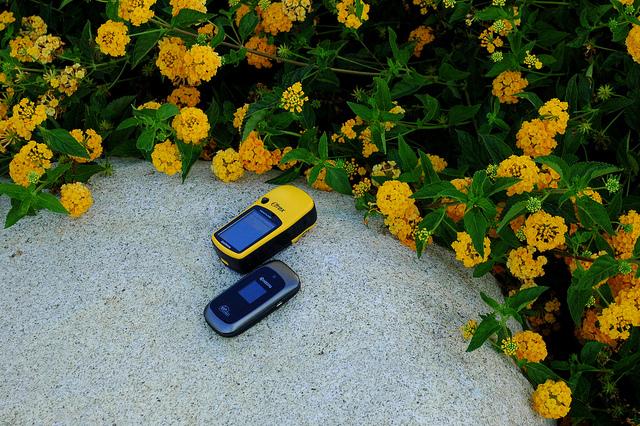What kind of flowers are shown?
Write a very short answer. Marigolds. What are the devices sitting on?
Answer briefly. Rock. Why would someone want to carry these two devices?
Concise answer only. To talk. 